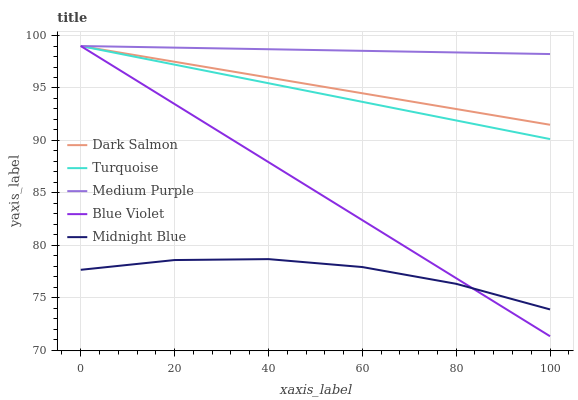Does Midnight Blue have the minimum area under the curve?
Answer yes or no. Yes. Does Medium Purple have the maximum area under the curve?
Answer yes or no. Yes. Does Turquoise have the minimum area under the curve?
Answer yes or no. No. Does Turquoise have the maximum area under the curve?
Answer yes or no. No. Is Dark Salmon the smoothest?
Answer yes or no. Yes. Is Midnight Blue the roughest?
Answer yes or no. Yes. Is Turquoise the smoothest?
Answer yes or no. No. Is Turquoise the roughest?
Answer yes or no. No. Does Blue Violet have the lowest value?
Answer yes or no. Yes. Does Turquoise have the lowest value?
Answer yes or no. No. Does Blue Violet have the highest value?
Answer yes or no. Yes. Does Midnight Blue have the highest value?
Answer yes or no. No. Is Midnight Blue less than Dark Salmon?
Answer yes or no. Yes. Is Turquoise greater than Midnight Blue?
Answer yes or no. Yes. Does Midnight Blue intersect Blue Violet?
Answer yes or no. Yes. Is Midnight Blue less than Blue Violet?
Answer yes or no. No. Is Midnight Blue greater than Blue Violet?
Answer yes or no. No. Does Midnight Blue intersect Dark Salmon?
Answer yes or no. No. 